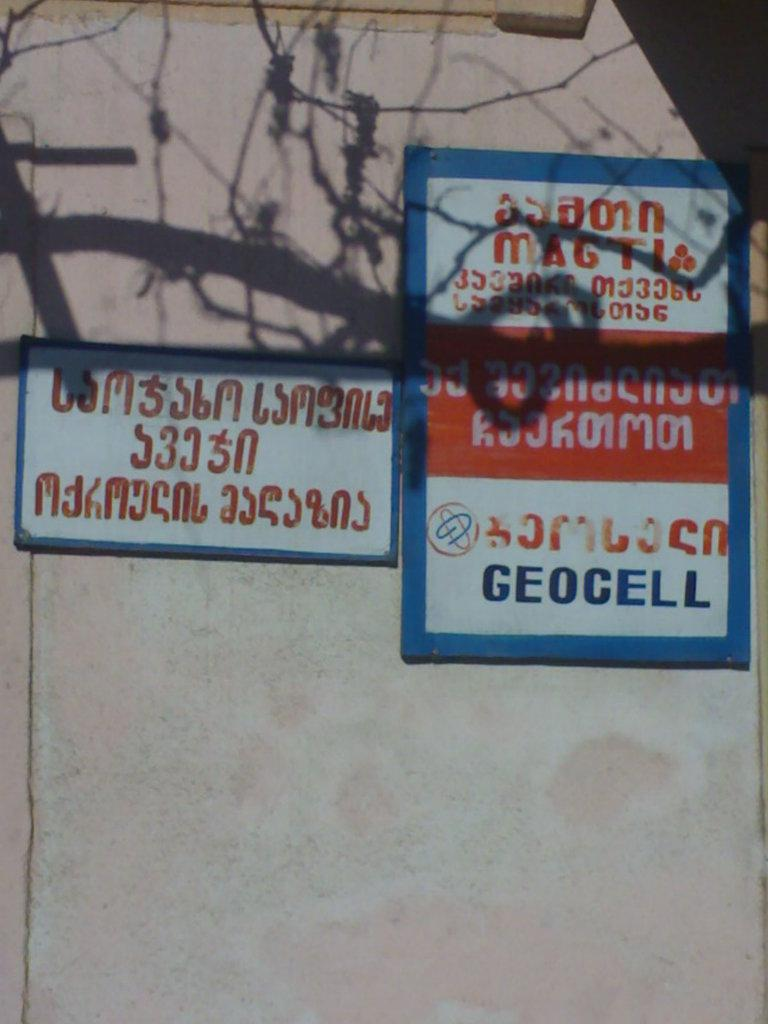Provide a one-sentence caption for the provided image. Two signs on a wall outdoors with one saying "Geocell". 